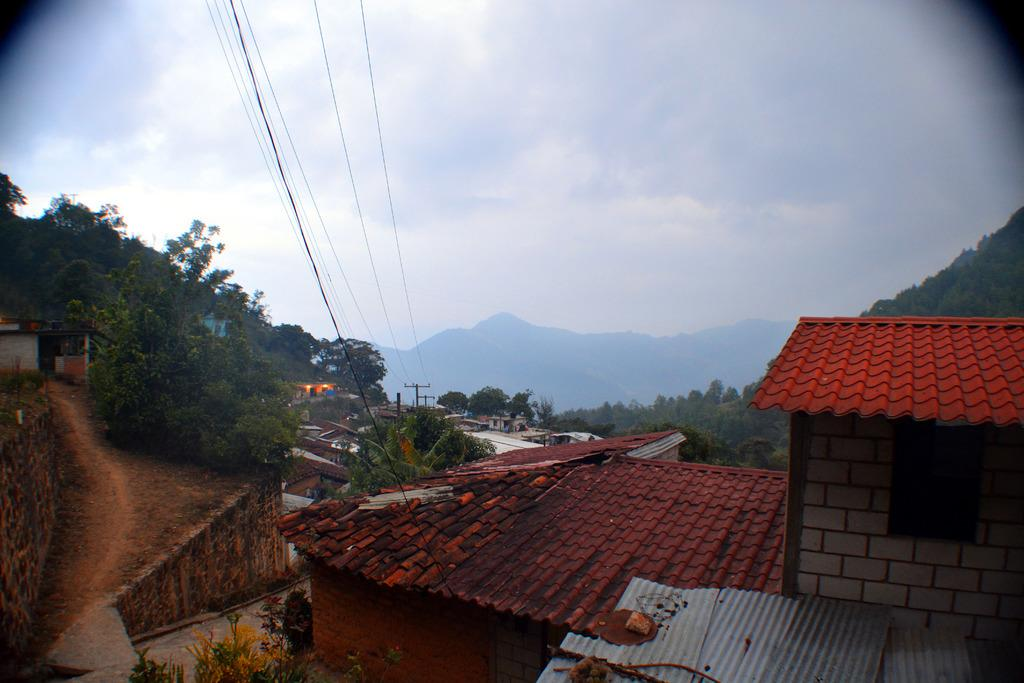What type of natural elements are in the center of the image? There are seeds and trees in the center of the image. What structures can be seen in the image? Poles are visible in the image. What is connected to the poles in the image? There are wires at the top of the image. What is visible at the top of the image besides the wires? The sky is visible at the top of the image. What type of worm can be seen crawling on the poles in the image? There are no worms present in the image; it only features seeds, trees, poles, wires, and the sky. 